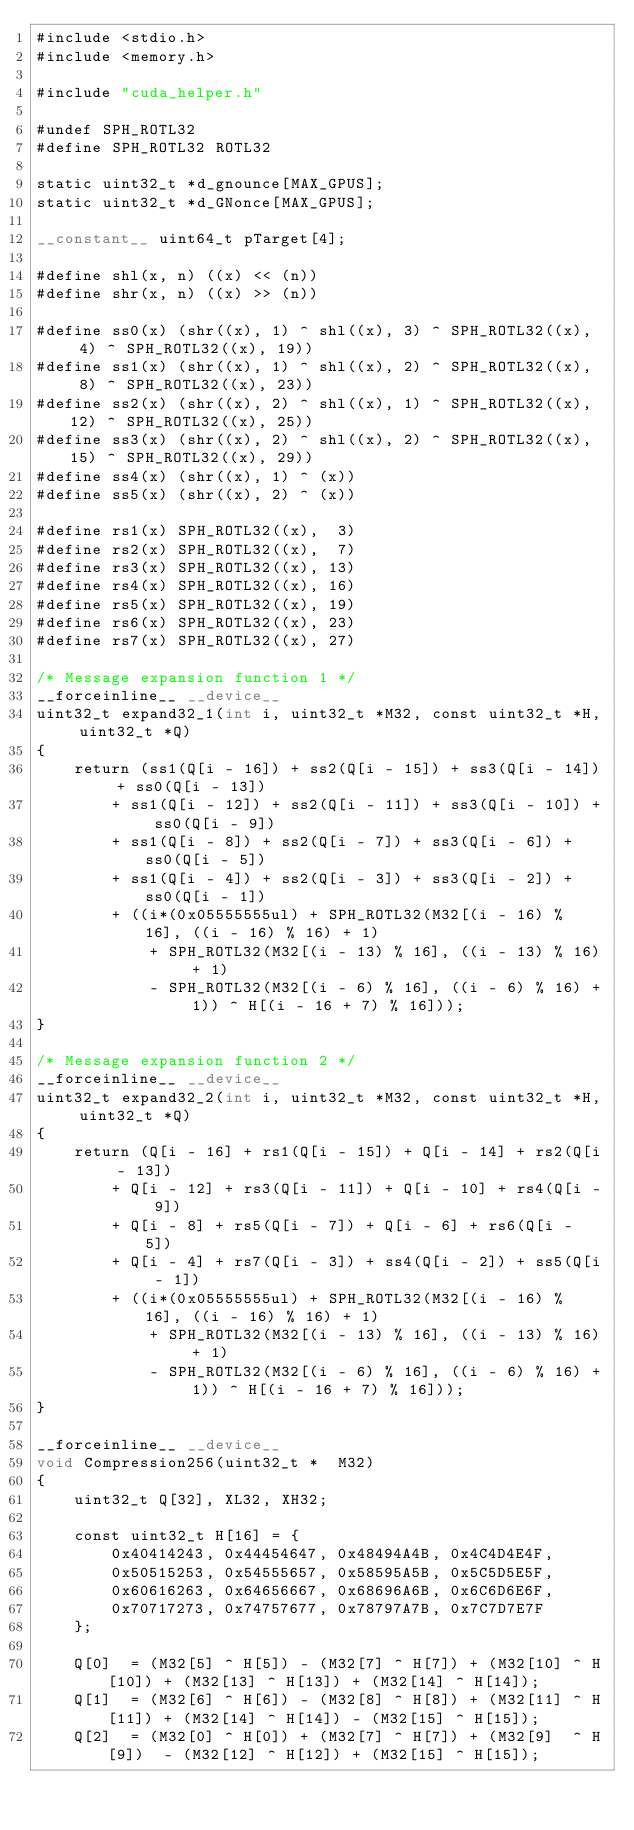<code> <loc_0><loc_0><loc_500><loc_500><_Cuda_>#include <stdio.h>
#include <memory.h>

#include "cuda_helper.h"

#undef SPH_ROTL32
#define SPH_ROTL32 ROTL32

static uint32_t *d_gnounce[MAX_GPUS];
static uint32_t *d_GNonce[MAX_GPUS];

__constant__ uint64_t pTarget[4];

#define shl(x, n) ((x) << (n))
#define shr(x, n) ((x) >> (n))

#define ss0(x) (shr((x), 1) ^ shl((x), 3) ^ SPH_ROTL32((x),  4) ^ SPH_ROTL32((x), 19))
#define ss1(x) (shr((x), 1) ^ shl((x), 2) ^ SPH_ROTL32((x),  8) ^ SPH_ROTL32((x), 23))
#define ss2(x) (shr((x), 2) ^ shl((x), 1) ^ SPH_ROTL32((x), 12) ^ SPH_ROTL32((x), 25))
#define ss3(x) (shr((x), 2) ^ shl((x), 2) ^ SPH_ROTL32((x), 15) ^ SPH_ROTL32((x), 29))
#define ss4(x) (shr((x), 1) ^ (x))
#define ss5(x) (shr((x), 2) ^ (x))

#define rs1(x) SPH_ROTL32((x),  3)
#define rs2(x) SPH_ROTL32((x),  7)
#define rs3(x) SPH_ROTL32((x), 13)
#define rs4(x) SPH_ROTL32((x), 16)
#define rs5(x) SPH_ROTL32((x), 19)
#define rs6(x) SPH_ROTL32((x), 23)
#define rs7(x) SPH_ROTL32((x), 27)

/* Message expansion function 1 */
__forceinline__ __device__
uint32_t expand32_1(int i, uint32_t *M32, const uint32_t *H, uint32_t *Q)
{
	return (ss1(Q[i - 16]) + ss2(Q[i - 15]) + ss3(Q[i - 14]) + ss0(Q[i - 13])
		+ ss1(Q[i - 12]) + ss2(Q[i - 11]) + ss3(Q[i - 10]) + ss0(Q[i - 9])
		+ ss1(Q[i - 8]) + ss2(Q[i - 7]) + ss3(Q[i - 6]) + ss0(Q[i - 5])
		+ ss1(Q[i - 4]) + ss2(Q[i - 3]) + ss3(Q[i - 2]) + ss0(Q[i - 1])
		+ ((i*(0x05555555ul) + SPH_ROTL32(M32[(i - 16) % 16], ((i - 16) % 16) + 1)
			+ SPH_ROTL32(M32[(i - 13) % 16], ((i - 13) % 16) + 1)
			- SPH_ROTL32(M32[(i - 6) % 16], ((i - 6) % 16) + 1)) ^ H[(i - 16 + 7) % 16]));
}

/* Message expansion function 2 */
__forceinline__ __device__
uint32_t expand32_2(int i, uint32_t *M32, const uint32_t *H, uint32_t *Q)
{
	return (Q[i - 16] + rs1(Q[i - 15]) + Q[i - 14] + rs2(Q[i - 13])
		+ Q[i - 12] + rs3(Q[i - 11]) + Q[i - 10] + rs4(Q[i - 9])
		+ Q[i - 8] + rs5(Q[i - 7]) + Q[i - 6] + rs6(Q[i - 5])
		+ Q[i - 4] + rs7(Q[i - 3]) + ss4(Q[i - 2]) + ss5(Q[i - 1])
		+ ((i*(0x05555555ul) + SPH_ROTL32(M32[(i - 16) % 16], ((i - 16) % 16) + 1)
			+ SPH_ROTL32(M32[(i - 13) % 16], ((i - 13) % 16) + 1)
			- SPH_ROTL32(M32[(i - 6) % 16], ((i - 6) % 16) + 1)) ^ H[(i - 16 + 7) % 16]));
}

__forceinline__ __device__
void Compression256(uint32_t *  M32)
{
	uint32_t Q[32], XL32, XH32;

	const uint32_t H[16] = {
		0x40414243, 0x44454647, 0x48494A4B, 0x4C4D4E4F,
		0x50515253, 0x54555657, 0x58595A5B, 0x5C5D5E5F,
		0x60616263, 0x64656667, 0x68696A6B, 0x6C6D6E6F,
		0x70717273, 0x74757677, 0x78797A7B, 0x7C7D7E7F
	};

	Q[0]  = (M32[5] ^ H[5]) - (M32[7] ^ H[7]) + (M32[10] ^ H[10]) + (M32[13] ^ H[13]) + (M32[14] ^ H[14]);
	Q[1]  = (M32[6] ^ H[6]) - (M32[8] ^ H[8]) + (M32[11] ^ H[11]) + (M32[14] ^ H[14]) - (M32[15] ^ H[15]);
	Q[2]  = (M32[0] ^ H[0]) + (M32[7] ^ H[7]) + (M32[9]  ^ H[9])  - (M32[12] ^ H[12]) + (M32[15] ^ H[15]);</code> 